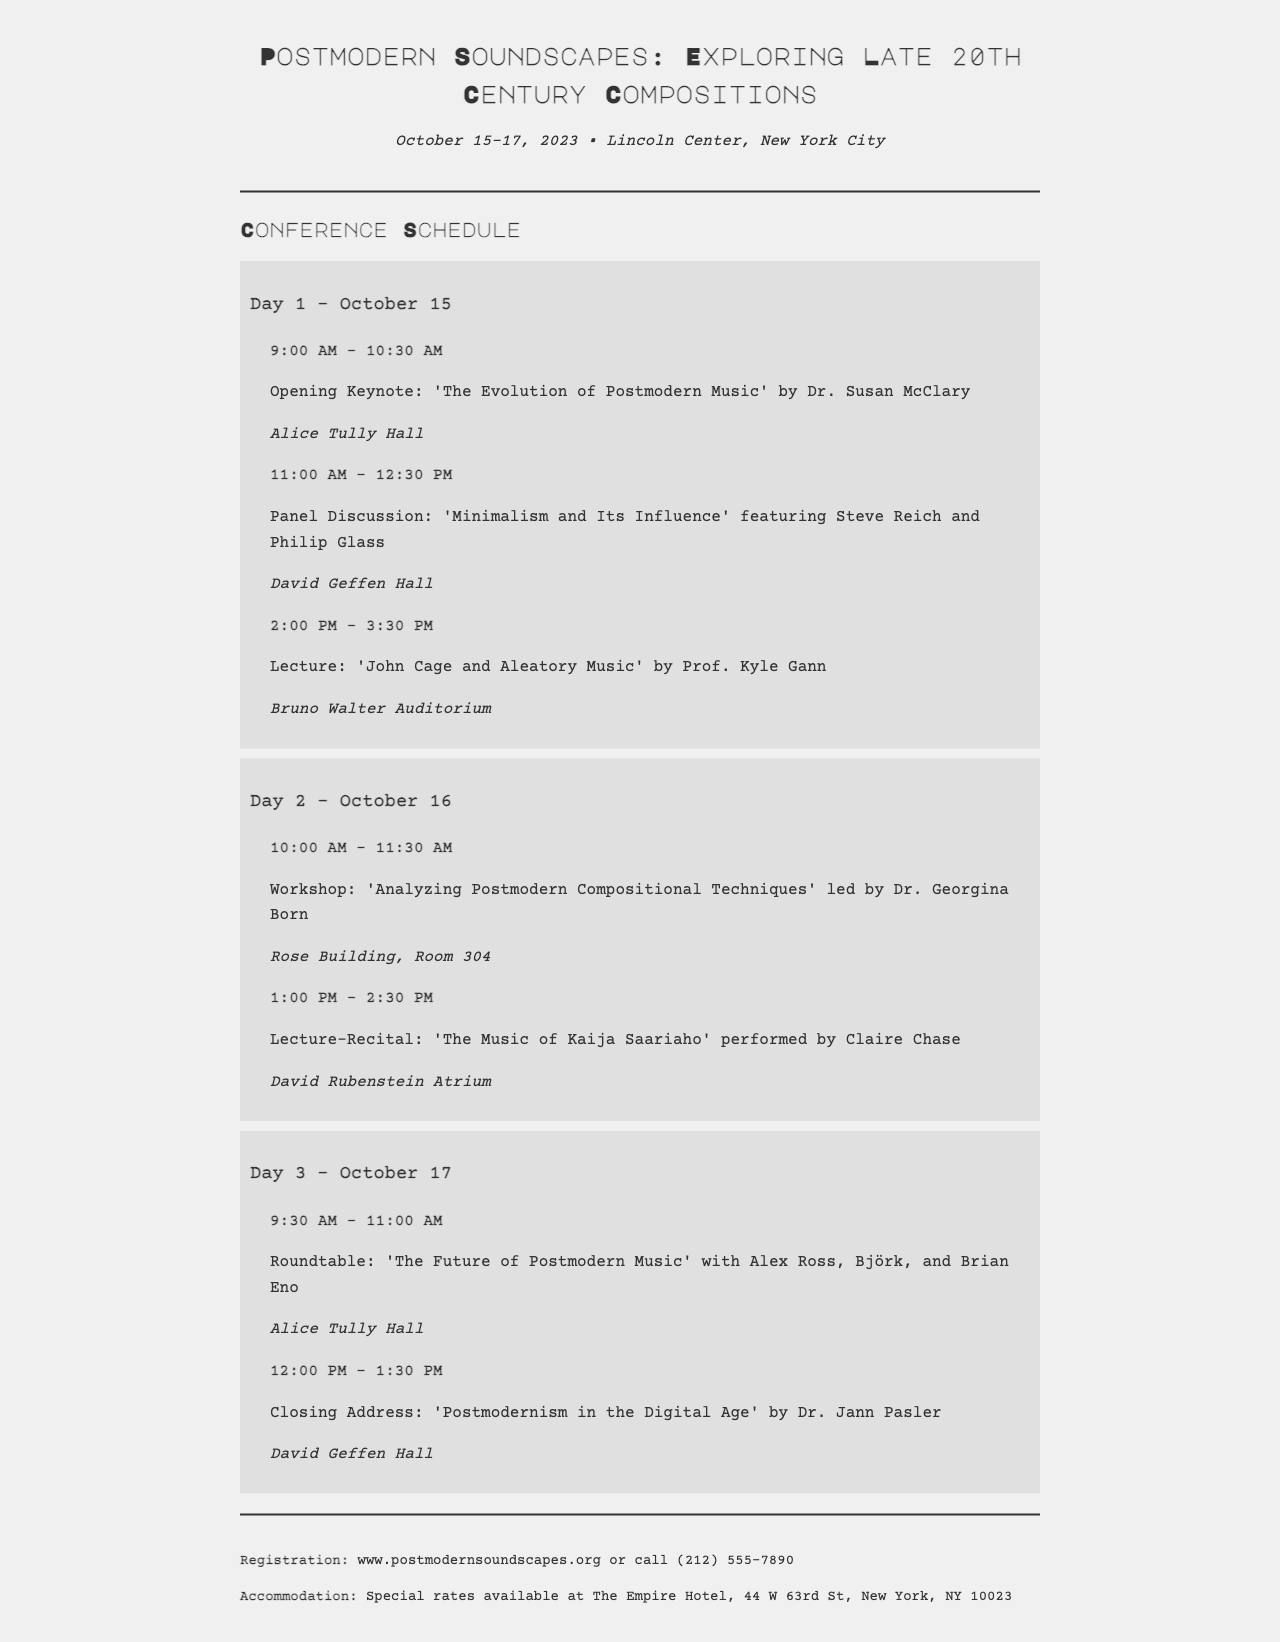What are the dates of the conference? The conference dates are clearly stated in the document as October 15-17, 2023.
Answer: October 15-17, 2023 Who is giving the opening keynote? The opening keynote is mentioned along with the speaker's name, which is Dr. Susan McClary.
Answer: Dr. Susan McClary What is the location of the workshop on Day 2? The document specifies the location of the workshop on Day 2, which is the Rose Building, Room 304.
Answer: Rose Building, Room 304 Which day features a roundtable discussion? The roundtable discussion is listed under Day 3 of the conference schedule.
Answer: Day 3 How many events are scheduled on Day 1? The schedule outlines three events occurring on Day 1, as indicated by the number of event listings.
Answer: 3 What is the closing address topic? The topic of the closing address is ‘Postmodernism in the Digital Age’ as stated in the event description.
Answer: Postmodernism in the Digital Age Name one of the speakers at the panel discussion. The document features names of speakers at the panel discussion, among which one is Steve Reich.
Answer: Steve Reich What time does the workshop begin on Day 2? The document details the start time of the workshop on Day 2, which is 10:00 AM.
Answer: 10:00 AM Where can one register for the conference? The registration information is provided, indicating the online source as www.postmodernsoundscapes.org.
Answer: www.postmodernsoundscapes.org 